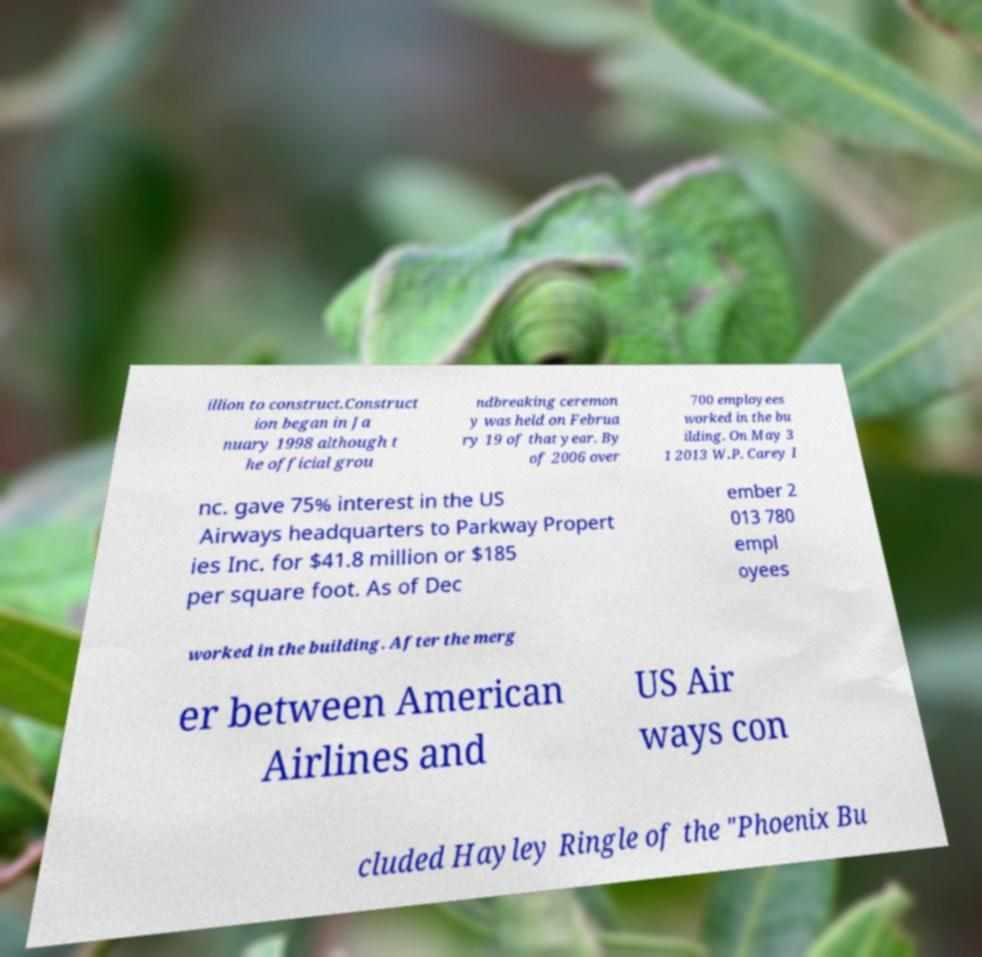Can you read and provide the text displayed in the image?This photo seems to have some interesting text. Can you extract and type it out for me? illion to construct.Construct ion began in Ja nuary 1998 although t he official grou ndbreaking ceremon y was held on Februa ry 19 of that year. By of 2006 over 700 employees worked in the bu ilding. On May 3 1 2013 W.P. Carey I nc. gave 75% interest in the US Airways headquarters to Parkway Propert ies Inc. for $41.8 million or $185 per square foot. As of Dec ember 2 013 780 empl oyees worked in the building. After the merg er between American Airlines and US Air ways con cluded Hayley Ringle of the "Phoenix Bu 